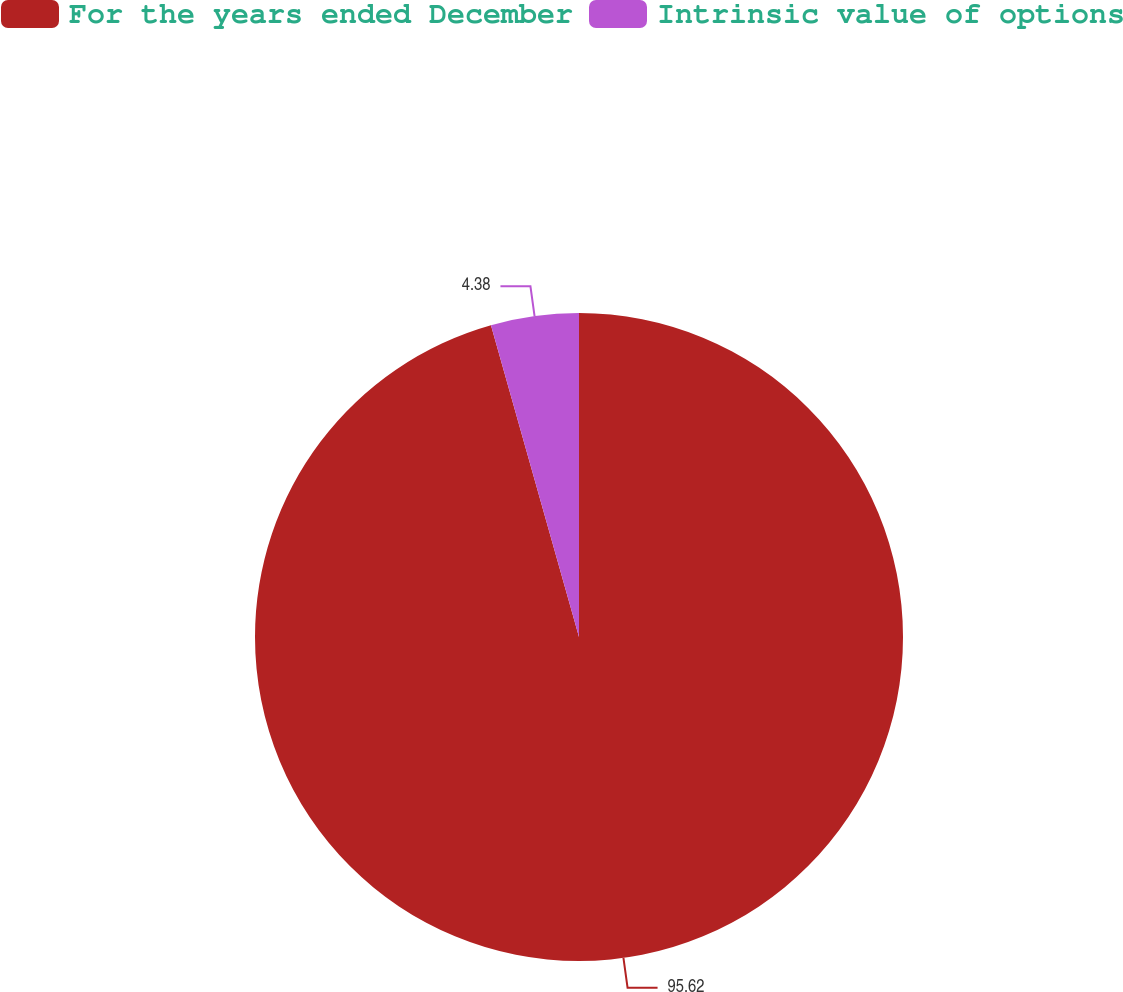Convert chart. <chart><loc_0><loc_0><loc_500><loc_500><pie_chart><fcel>For the years ended December<fcel>Intrinsic value of options<nl><fcel>95.62%<fcel>4.38%<nl></chart> 